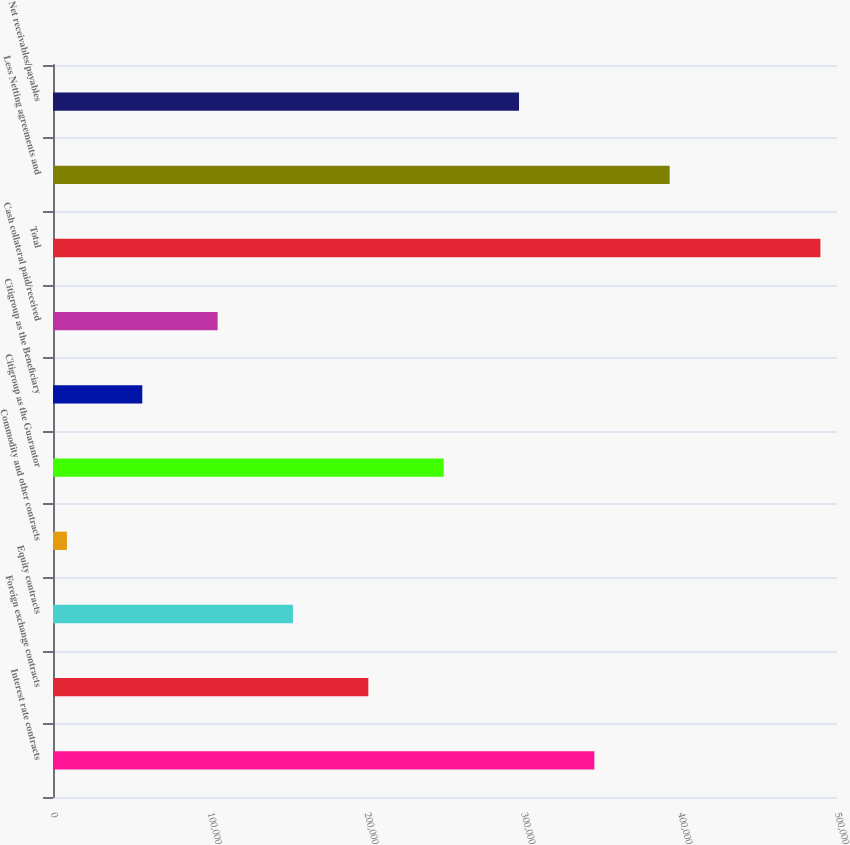Convert chart. <chart><loc_0><loc_0><loc_500><loc_500><bar_chart><fcel>Interest rate contracts<fcel>Foreign exchange contracts<fcel>Equity contracts<fcel>Commodity and other contracts<fcel>Citigroup as the Guarantor<fcel>Citigroup as the Beneficiary<fcel>Cash collateral paid/received<fcel>Total<fcel>Less Netting agreements and<fcel>Net receivables/payables<nl><fcel>345258<fcel>201099<fcel>153046<fcel>8887<fcel>249152<fcel>56940<fcel>104993<fcel>489417<fcel>393311<fcel>297205<nl></chart> 